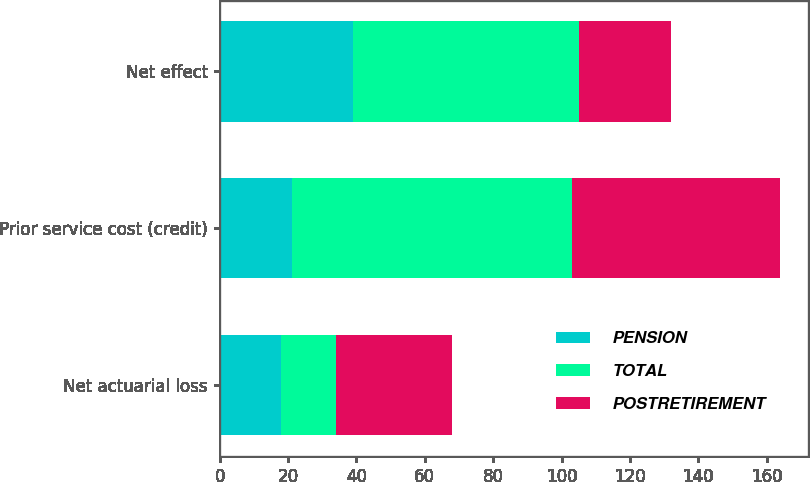<chart> <loc_0><loc_0><loc_500><loc_500><stacked_bar_chart><ecel><fcel>Net actuarial loss<fcel>Prior service cost (credit)<fcel>Net effect<nl><fcel>PENSION<fcel>18<fcel>21<fcel>39<nl><fcel>TOTAL<fcel>16<fcel>82<fcel>66<nl><fcel>POSTRETIREMENT<fcel>34<fcel>61<fcel>27<nl></chart> 